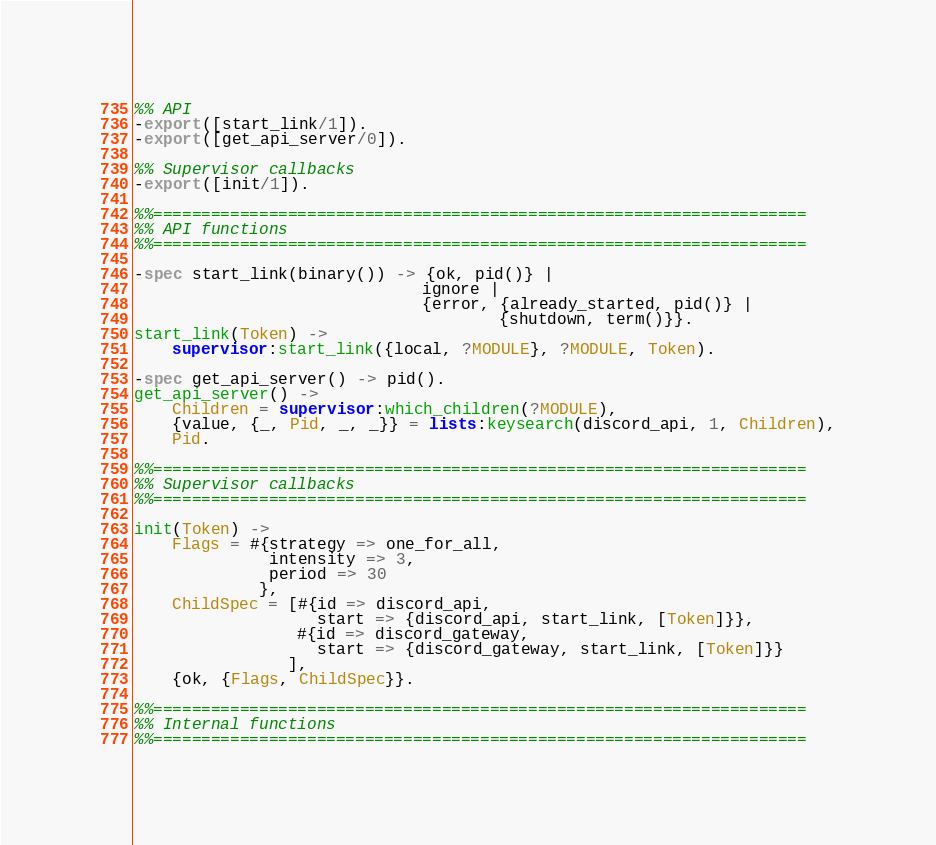<code> <loc_0><loc_0><loc_500><loc_500><_Erlang_>
%% API
-export([start_link/1]).
-export([get_api_server/0]).

%% Supervisor callbacks
-export([init/1]).

%%====================================================================
%% API functions
%%====================================================================

-spec start_link(binary()) -> {ok, pid()} |
                              ignore |
                              {error, {already_started, pid()} |
                                      {shutdown, term()}}.
start_link(Token) ->
    supervisor:start_link({local, ?MODULE}, ?MODULE, Token).

-spec get_api_server() -> pid().
get_api_server() ->
    Children = supervisor:which_children(?MODULE),
    {value, {_, Pid, _, _}} = lists:keysearch(discord_api, 1, Children),
    Pid.

%%====================================================================
%% Supervisor callbacks
%%====================================================================

init(Token) ->
    Flags = #{strategy => one_for_all,
              intensity => 3,
              period => 30
             },
    ChildSpec = [#{id => discord_api,
                   start => {discord_api, start_link, [Token]}},
                 #{id => discord_gateway,
                   start => {discord_gateway, start_link, [Token]}}
                ],
    {ok, {Flags, ChildSpec}}.

%%====================================================================
%% Internal functions
%%====================================================================
</code> 